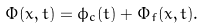Convert formula to latex. <formula><loc_0><loc_0><loc_500><loc_500>\Phi ( x , t ) = \phi _ { c } ( t ) + \Phi _ { f } ( x , t ) .</formula> 